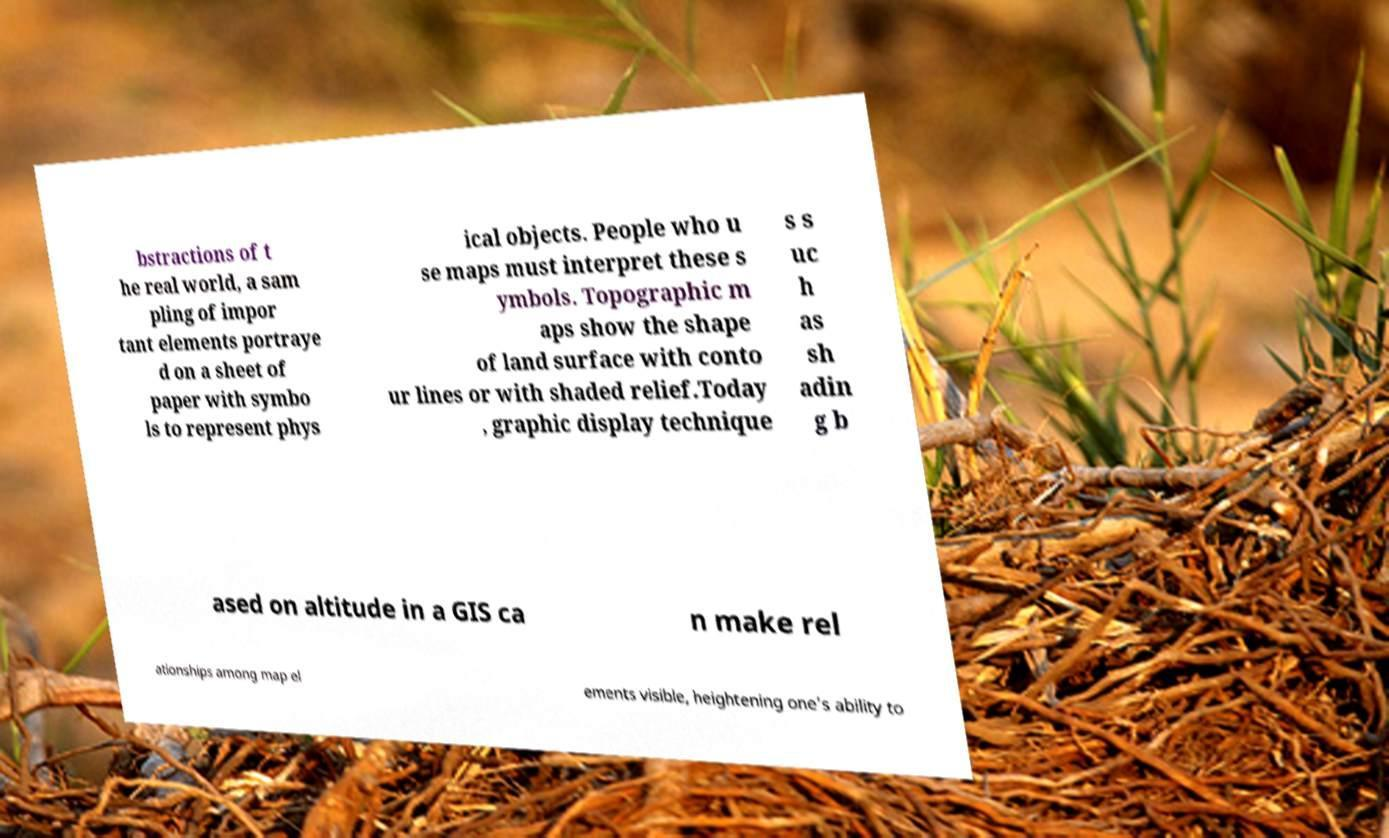Please identify and transcribe the text found in this image. bstractions of t he real world, a sam pling of impor tant elements portraye d on a sheet of paper with symbo ls to represent phys ical objects. People who u se maps must interpret these s ymbols. Topographic m aps show the shape of land surface with conto ur lines or with shaded relief.Today , graphic display technique s s uc h as sh adin g b ased on altitude in a GIS ca n make rel ationships among map el ements visible, heightening one's ability to 